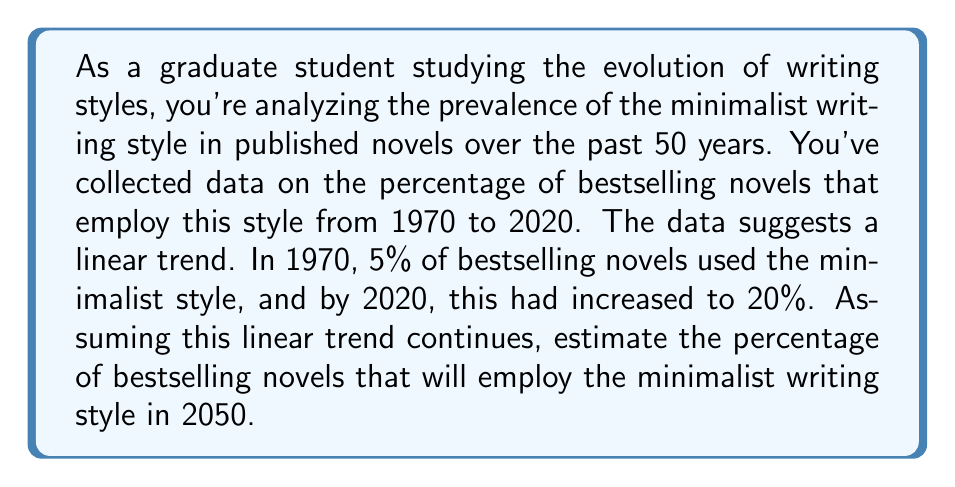What is the answer to this math problem? To solve this problem, we need to use a linear equation. Let's break it down step-by-step:

1. Identify the variables:
   Let $x$ represent the number of years since 1970
   Let $y$ represent the percentage of bestselling novels using the minimalist style

2. Find two points from the given data:
   (1970, 5%) corresponds to (0, 5)
   (2020, 20%) corresponds to (50, 20)

3. Calculate the slope $(m)$ of the line:
   $$m = \frac{y_2 - y_1}{x_2 - x_1} = \frac{20 - 5}{50 - 0} = \frac{15}{50} = 0.3$$

4. Use the point-slope form of a line to create the equation:
   $y - y_1 = m(x - x_1)$
   $y - 5 = 0.3(x - 0)$
   $y = 0.3x + 5$

5. To estimate the percentage in 2050:
   2050 is 80 years after 1970, so $x = 80$
   $$y = 0.3(80) + 5 = 24 + 5 = 29$$

Therefore, if the linear trend continues, we estimate that 29% of bestselling novels will employ the minimalist writing style in 2050.
Answer: 29% 